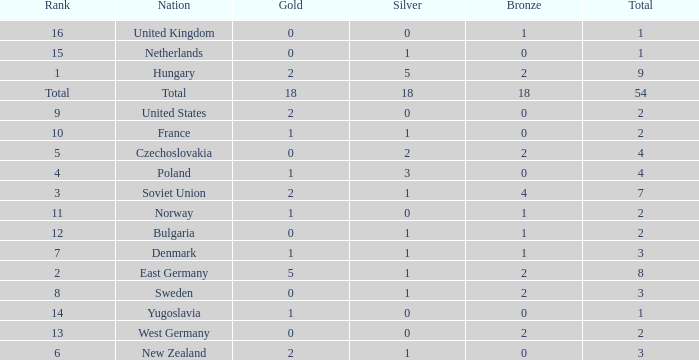What is the lowest total for those receiving less than 18 but more than 14? 1.0. 